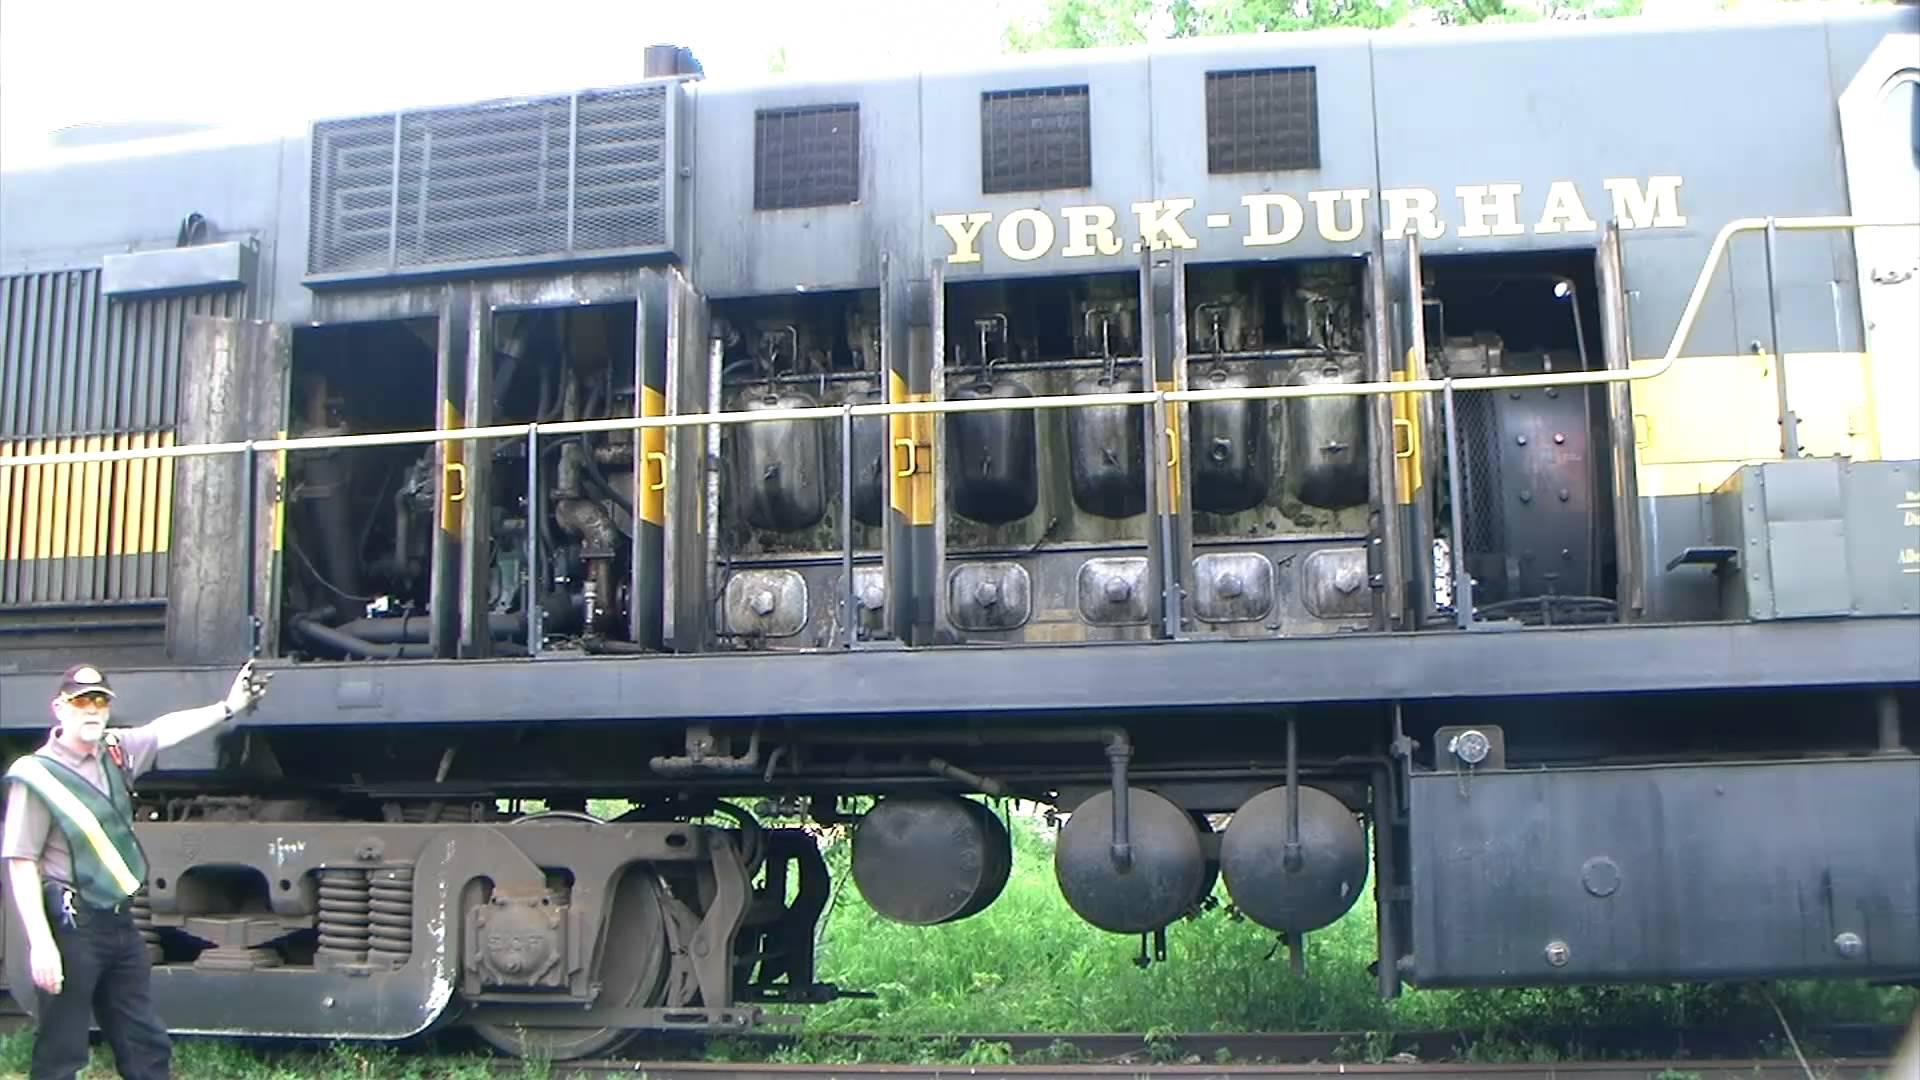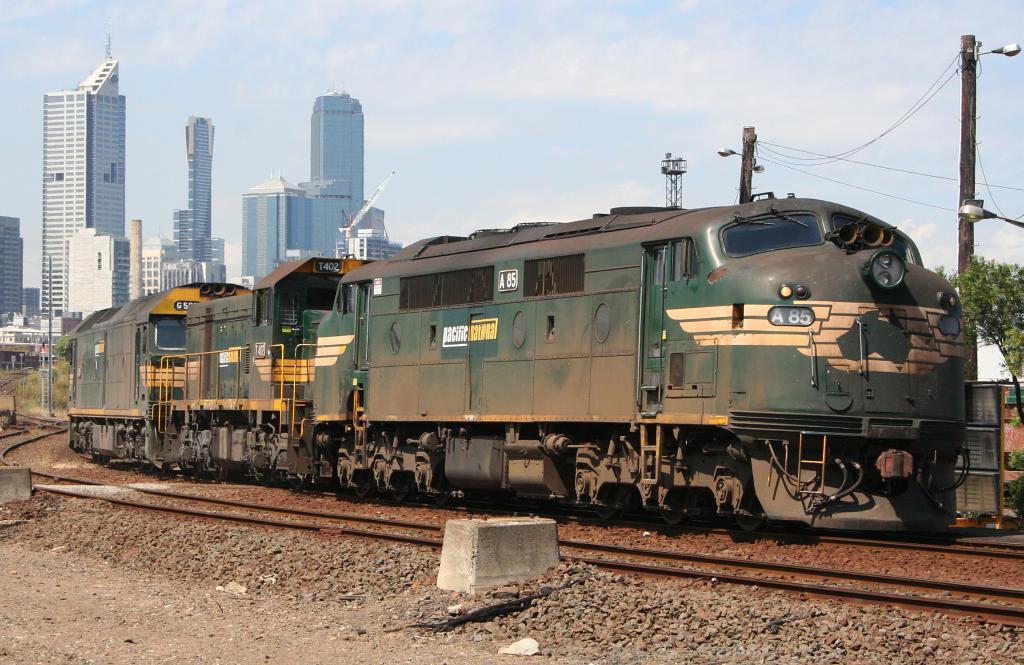The first image is the image on the left, the second image is the image on the right. For the images shown, is this caption "All the trains depicted feature green coloring." true? Answer yes or no. No. 